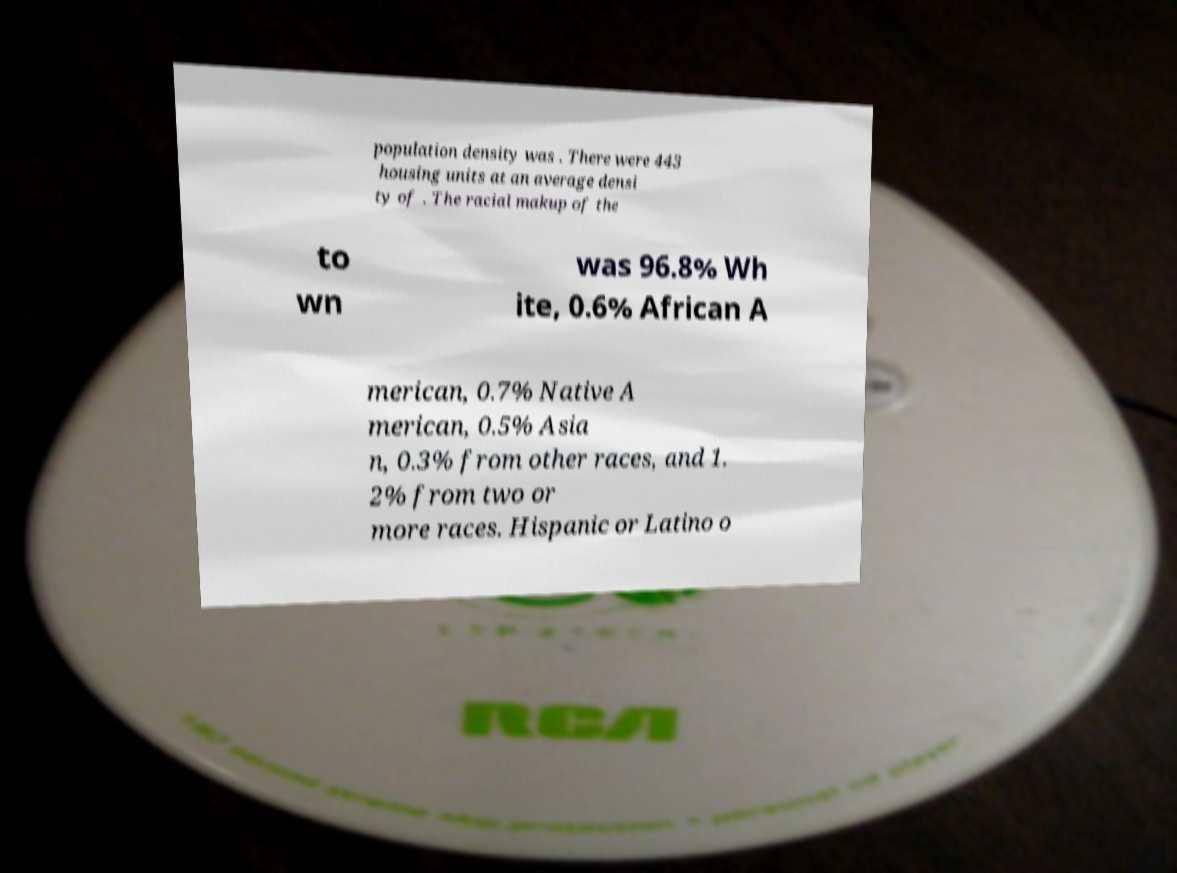Could you extract and type out the text from this image? population density was . There were 443 housing units at an average densi ty of . The racial makup of the to wn was 96.8% Wh ite, 0.6% African A merican, 0.7% Native A merican, 0.5% Asia n, 0.3% from other races, and 1. 2% from two or more races. Hispanic or Latino o 